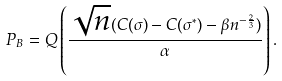Convert formula to latex. <formula><loc_0><loc_0><loc_500><loc_500>P _ { B } = Q \left ( \frac { \sqrt { n } ( C ( \sigma ) - C ( \sigma ^ { * } ) - \beta n ^ { - \frac { 2 } { 3 } } ) } { \alpha } \right ) .</formula> 